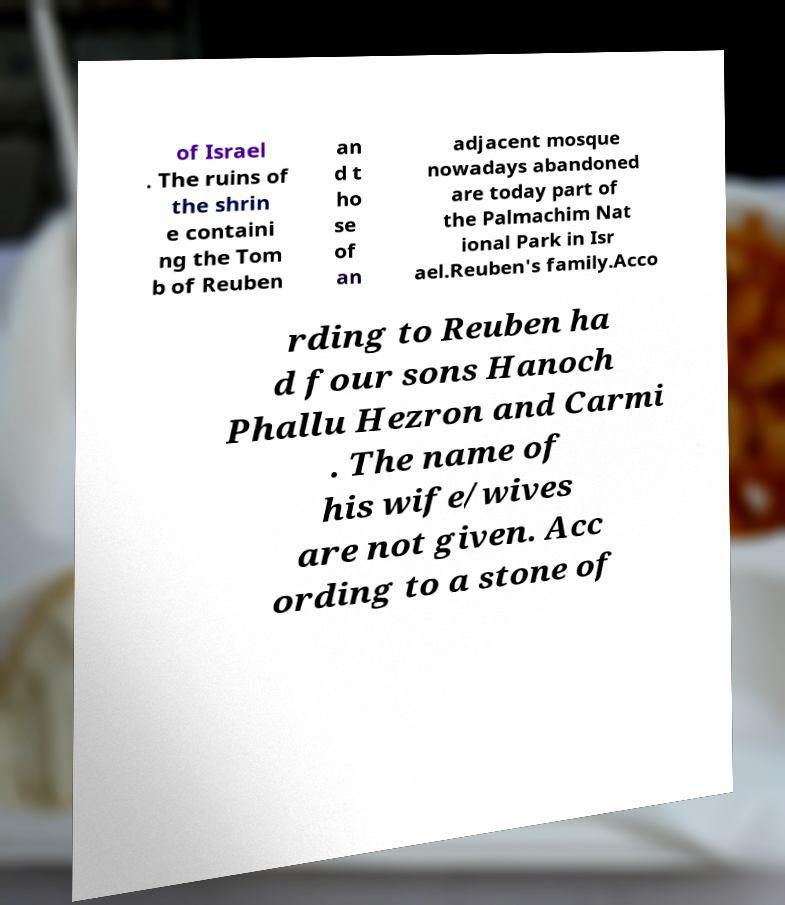Could you assist in decoding the text presented in this image and type it out clearly? of Israel . The ruins of the shrin e containi ng the Tom b of Reuben an d t ho se of an adjacent mosque nowadays abandoned are today part of the Palmachim Nat ional Park in Isr ael.Reuben's family.Acco rding to Reuben ha d four sons Hanoch Phallu Hezron and Carmi . The name of his wife/wives are not given. Acc ording to a stone of 